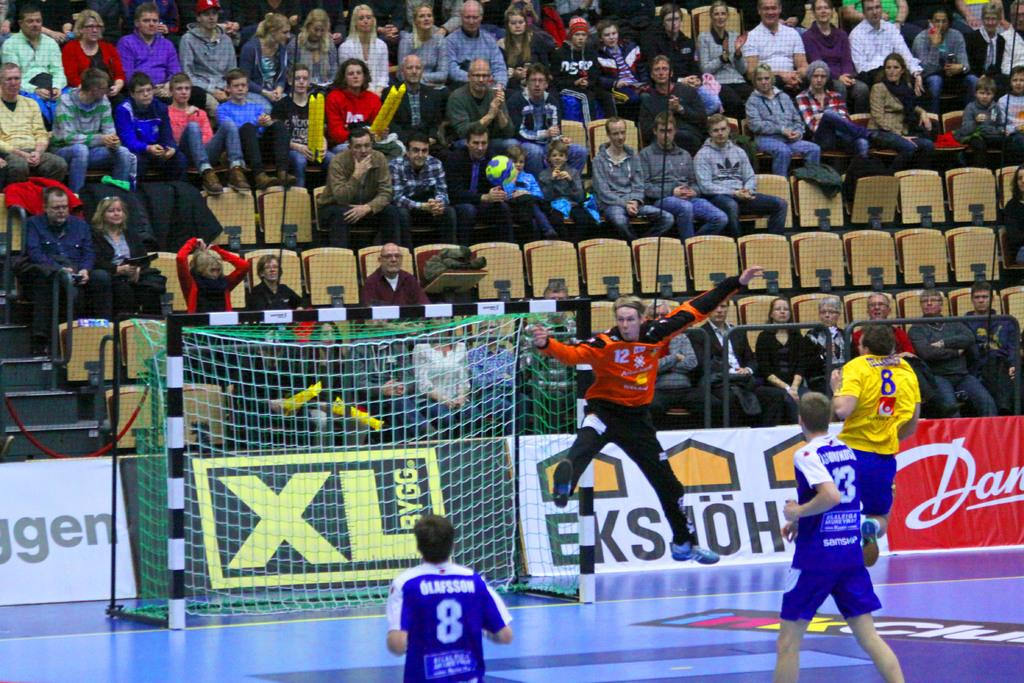<image>
Give a short and clear explanation of the subsequent image. XL Bygg sign on a black and gold poster board. 